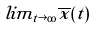Convert formula to latex. <formula><loc_0><loc_0><loc_500><loc_500>l i m _ { t \rightarrow \infty } \overline { x } ( t )</formula> 